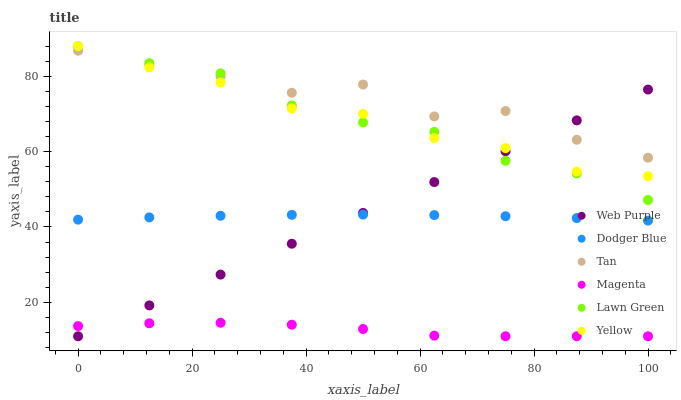Does Magenta have the minimum area under the curve?
Answer yes or no. Yes. Does Tan have the maximum area under the curve?
Answer yes or no. Yes. Does Yellow have the minimum area under the curve?
Answer yes or no. No. Does Yellow have the maximum area under the curve?
Answer yes or no. No. Is Web Purple the smoothest?
Answer yes or no. Yes. Is Tan the roughest?
Answer yes or no. Yes. Is Yellow the smoothest?
Answer yes or no. No. Is Yellow the roughest?
Answer yes or no. No. Does Web Purple have the lowest value?
Answer yes or no. Yes. Does Yellow have the lowest value?
Answer yes or no. No. Does Yellow have the highest value?
Answer yes or no. Yes. Does Web Purple have the highest value?
Answer yes or no. No. Is Magenta less than Lawn Green?
Answer yes or no. Yes. Is Tan greater than Magenta?
Answer yes or no. Yes. Does Yellow intersect Web Purple?
Answer yes or no. Yes. Is Yellow less than Web Purple?
Answer yes or no. No. Is Yellow greater than Web Purple?
Answer yes or no. No. Does Magenta intersect Lawn Green?
Answer yes or no. No. 